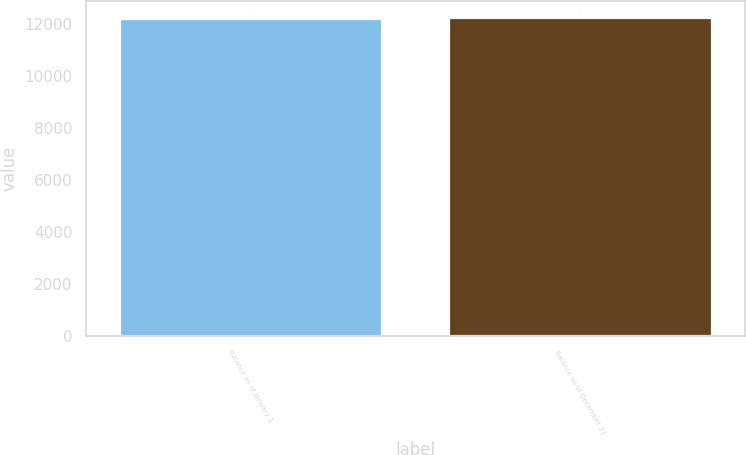<chart> <loc_0><loc_0><loc_500><loc_500><bar_chart><fcel>Balance as of January 1<fcel>Balance as of December 31<nl><fcel>12219<fcel>12255<nl></chart> 